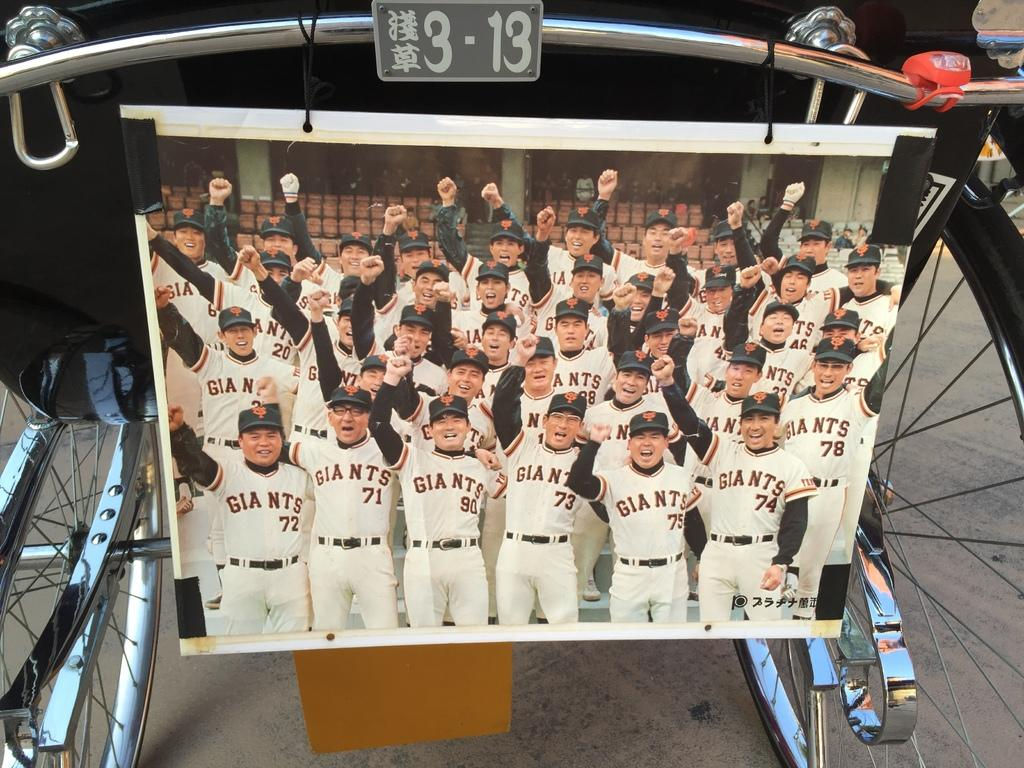<image>
Describe the image concisely. A team photograph of a Japanese baseball club called the Giants. 